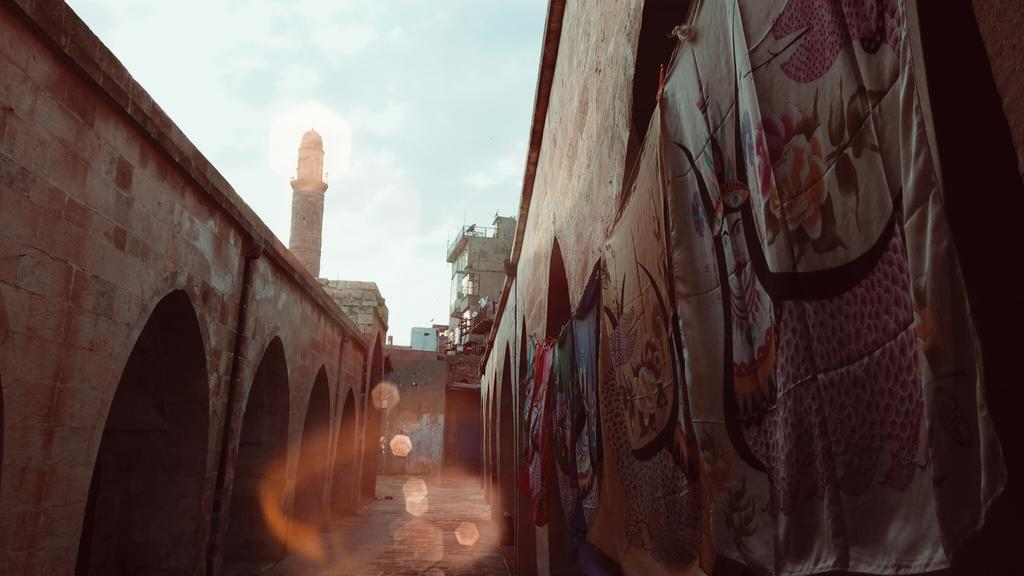What is present in the image that serves as a barrier or divider? There is a wall in the image. What can be seen flying in the image? There are flags in the image. What surface can be seen in the image that people might walk on? There is a walkway in the image. What type of structure can be seen in the background of the image? There is a building and a tower in the background of the image. What is visible in the sky in the image? The sky is visible in the background of the image. What type of cake is being served on the voyage in the image? There is no cake or voyage present in the image. What is the quiver used for in the image? There is no quiver present in the image. 